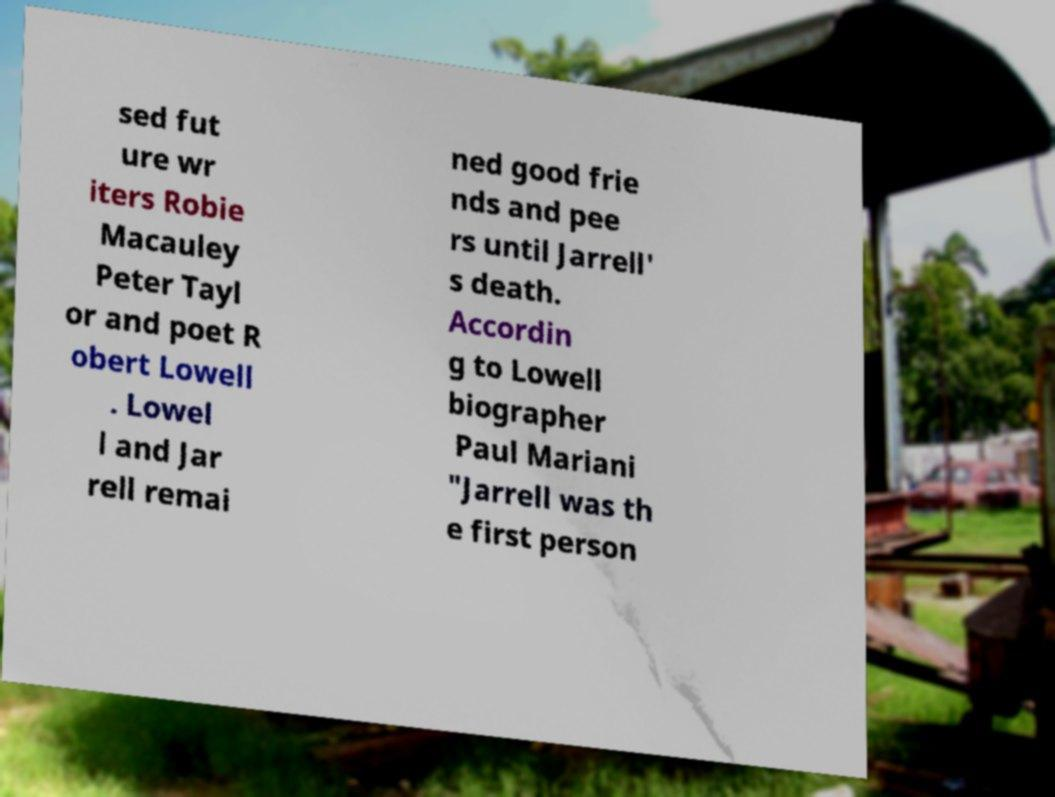Could you assist in decoding the text presented in this image and type it out clearly? sed fut ure wr iters Robie Macauley Peter Tayl or and poet R obert Lowell . Lowel l and Jar rell remai ned good frie nds and pee rs until Jarrell' s death. Accordin g to Lowell biographer Paul Mariani "Jarrell was th e first person 